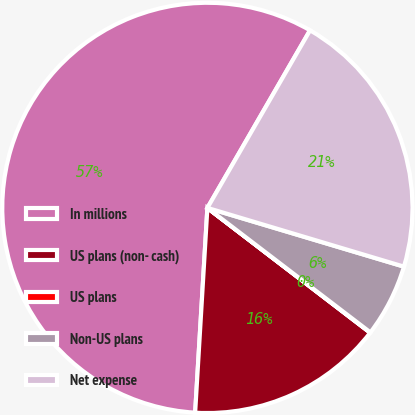Convert chart to OTSL. <chart><loc_0><loc_0><loc_500><loc_500><pie_chart><fcel>In millions<fcel>US plans (non- cash)<fcel>US plans<fcel>Non-US plans<fcel>Net expense<nl><fcel>57.39%<fcel>15.54%<fcel>0.03%<fcel>5.76%<fcel>21.28%<nl></chart> 